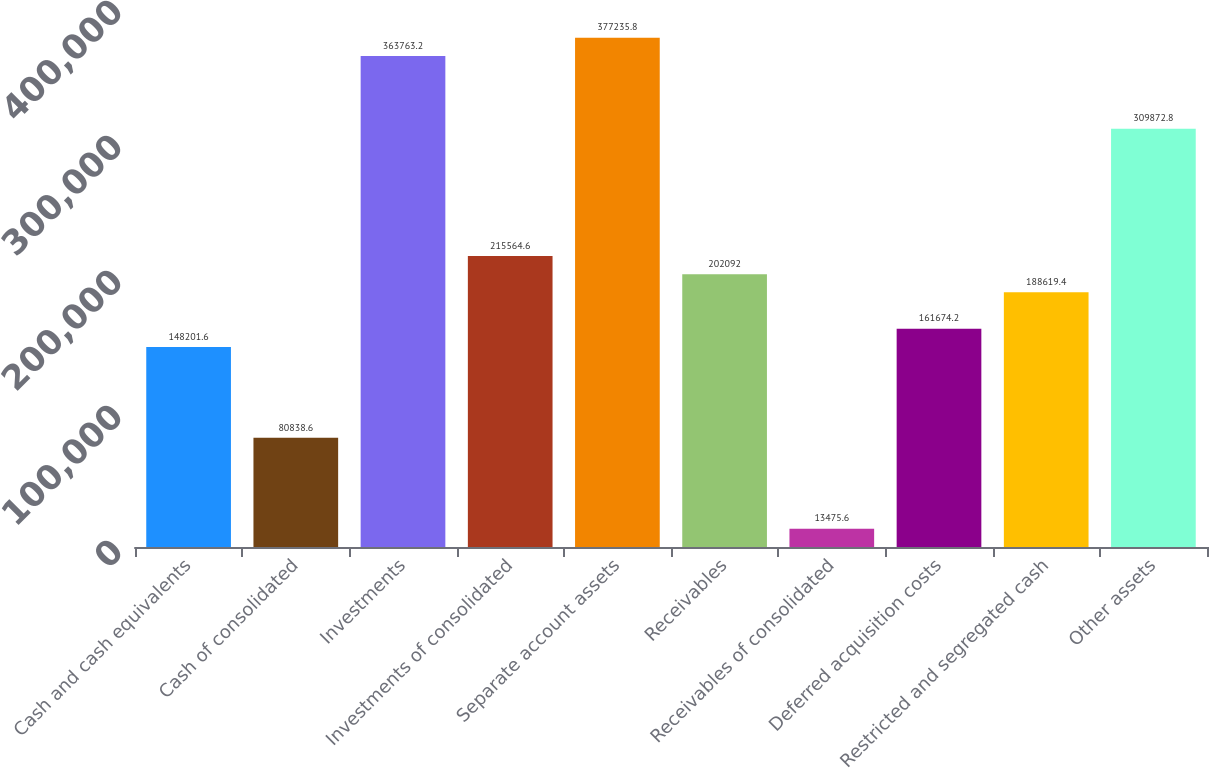Convert chart to OTSL. <chart><loc_0><loc_0><loc_500><loc_500><bar_chart><fcel>Cash and cash equivalents<fcel>Cash of consolidated<fcel>Investments<fcel>Investments of consolidated<fcel>Separate account assets<fcel>Receivables<fcel>Receivables of consolidated<fcel>Deferred acquisition costs<fcel>Restricted and segregated cash<fcel>Other assets<nl><fcel>148202<fcel>80838.6<fcel>363763<fcel>215565<fcel>377236<fcel>202092<fcel>13475.6<fcel>161674<fcel>188619<fcel>309873<nl></chart> 